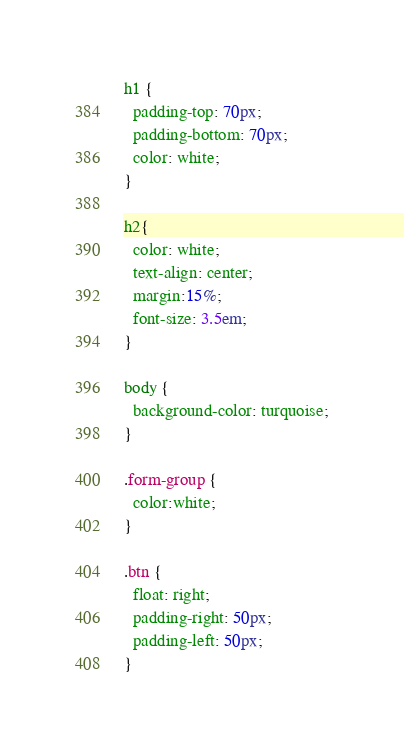Convert code to text. <code><loc_0><loc_0><loc_500><loc_500><_CSS_>h1 {
  padding-top: 70px;
  padding-bottom: 70px;
  color: white;
}

h2{
  color: white;
  text-align: center;
  margin:15%;
  font-size: 3.5em;
}

body {
  background-color: turquoise;
}

.form-group {
  color:white;
}

.btn {
  float: right;
  padding-right: 50px;
  padding-left: 50px;
}
</code> 